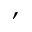Convert formula to latex. <formula><loc_0><loc_0><loc_500><loc_500>,</formula> 